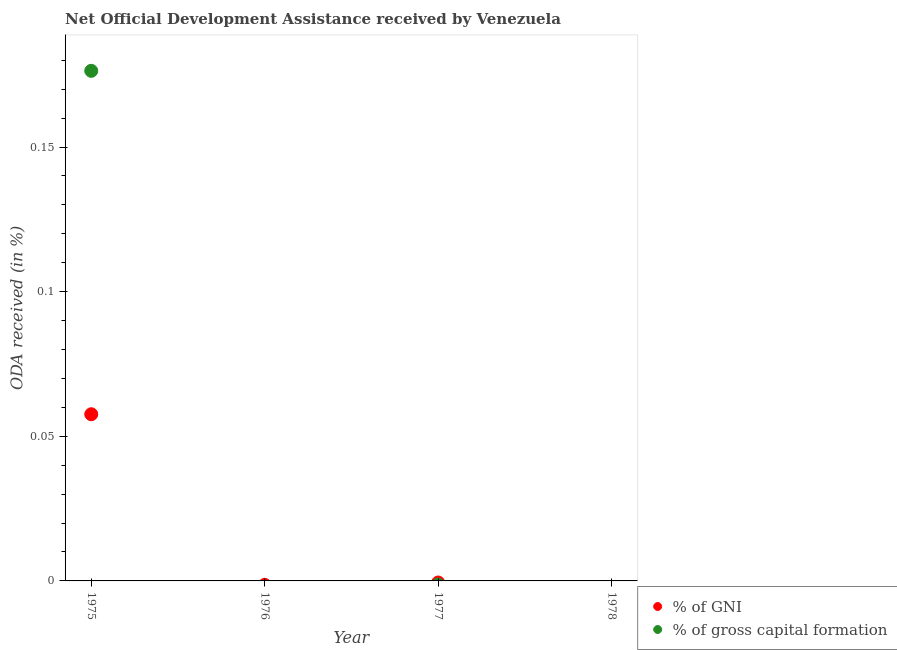What is the oda received as percentage of gross capital formation in 1975?
Ensure brevity in your answer.  0.18. Across all years, what is the maximum oda received as percentage of gni?
Your response must be concise. 0.06. Across all years, what is the minimum oda received as percentage of gni?
Ensure brevity in your answer.  0. In which year was the oda received as percentage of gross capital formation maximum?
Make the answer very short. 1975. What is the total oda received as percentage of gross capital formation in the graph?
Keep it short and to the point. 0.18. What is the difference between the oda received as percentage of gni in 1976 and the oda received as percentage of gross capital formation in 1977?
Make the answer very short. 0. What is the average oda received as percentage of gni per year?
Keep it short and to the point. 0.01. In the year 1975, what is the difference between the oda received as percentage of gni and oda received as percentage of gross capital formation?
Your answer should be compact. -0.12. In how many years, is the oda received as percentage of gni greater than 0.08 %?
Give a very brief answer. 0. What is the difference between the highest and the lowest oda received as percentage of gross capital formation?
Make the answer very short. 0.18. Is the oda received as percentage of gni strictly greater than the oda received as percentage of gross capital formation over the years?
Your answer should be compact. No. How many dotlines are there?
Ensure brevity in your answer.  2. How many years are there in the graph?
Make the answer very short. 4. What is the difference between two consecutive major ticks on the Y-axis?
Provide a succinct answer. 0.05. Does the graph contain any zero values?
Offer a terse response. Yes. Where does the legend appear in the graph?
Offer a terse response. Bottom right. How many legend labels are there?
Provide a short and direct response. 2. How are the legend labels stacked?
Offer a terse response. Vertical. What is the title of the graph?
Give a very brief answer. Net Official Development Assistance received by Venezuela. Does "Non-solid fuel" appear as one of the legend labels in the graph?
Give a very brief answer. No. What is the label or title of the Y-axis?
Offer a terse response. ODA received (in %). What is the ODA received (in %) in % of GNI in 1975?
Make the answer very short. 0.06. What is the ODA received (in %) in % of gross capital formation in 1975?
Your answer should be very brief. 0.18. What is the ODA received (in %) in % of GNI in 1976?
Offer a terse response. 0. What is the ODA received (in %) of % of GNI in 1977?
Give a very brief answer. 0. What is the ODA received (in %) in % of gross capital formation in 1977?
Offer a very short reply. 0. What is the ODA received (in %) in % of GNI in 1978?
Ensure brevity in your answer.  0. Across all years, what is the maximum ODA received (in %) of % of GNI?
Your response must be concise. 0.06. Across all years, what is the maximum ODA received (in %) in % of gross capital formation?
Give a very brief answer. 0.18. Across all years, what is the minimum ODA received (in %) of % of GNI?
Give a very brief answer. 0. Across all years, what is the minimum ODA received (in %) of % of gross capital formation?
Provide a succinct answer. 0. What is the total ODA received (in %) in % of GNI in the graph?
Your answer should be compact. 0.06. What is the total ODA received (in %) in % of gross capital formation in the graph?
Give a very brief answer. 0.18. What is the average ODA received (in %) of % of GNI per year?
Make the answer very short. 0.01. What is the average ODA received (in %) of % of gross capital formation per year?
Give a very brief answer. 0.04. In the year 1975, what is the difference between the ODA received (in %) in % of GNI and ODA received (in %) in % of gross capital formation?
Your answer should be very brief. -0.12. What is the difference between the highest and the lowest ODA received (in %) of % of GNI?
Give a very brief answer. 0.06. What is the difference between the highest and the lowest ODA received (in %) of % of gross capital formation?
Offer a terse response. 0.18. 